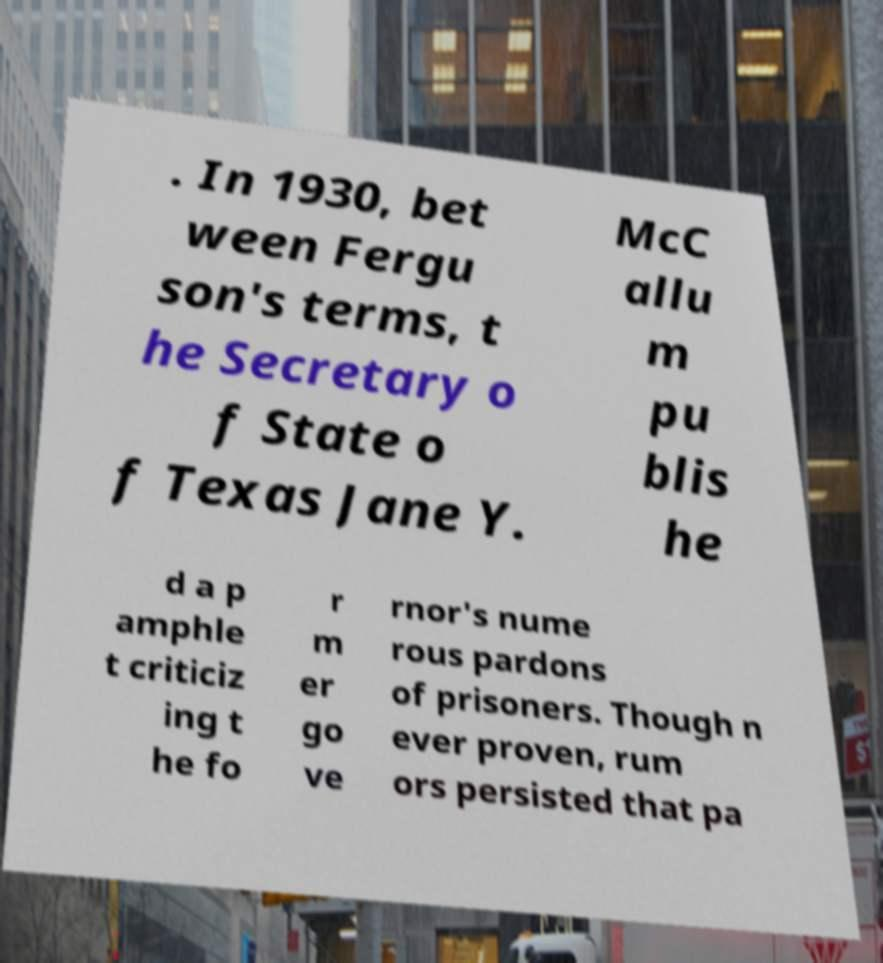I need the written content from this picture converted into text. Can you do that? . In 1930, bet ween Fergu son's terms, t he Secretary o f State o f Texas Jane Y. McC allu m pu blis he d a p amphle t criticiz ing t he fo r m er go ve rnor's nume rous pardons of prisoners. Though n ever proven, rum ors persisted that pa 